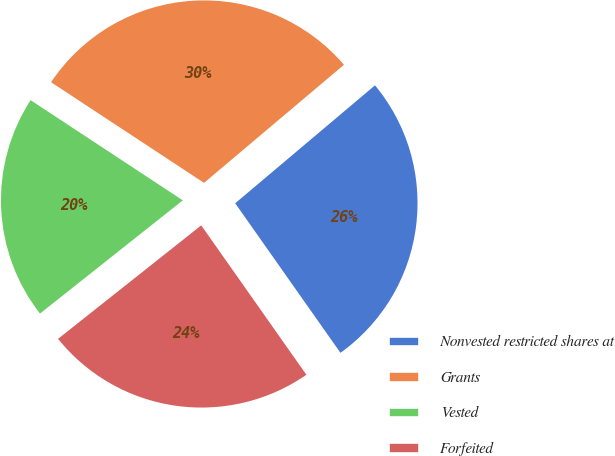Convert chart to OTSL. <chart><loc_0><loc_0><loc_500><loc_500><pie_chart><fcel>Nonvested restricted shares at<fcel>Grants<fcel>Vested<fcel>Forfeited<nl><fcel>26.39%<fcel>29.58%<fcel>19.93%<fcel>24.09%<nl></chart> 